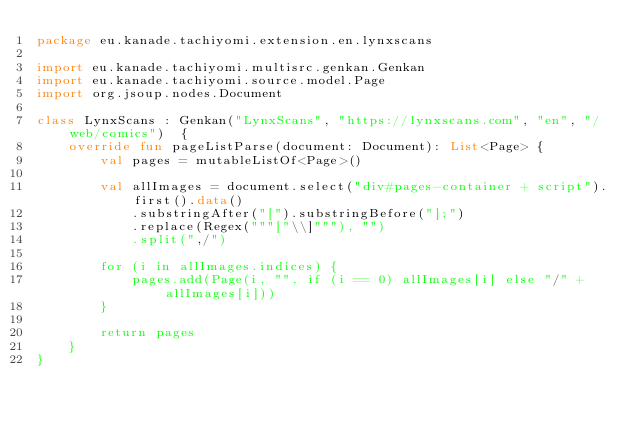Convert code to text. <code><loc_0><loc_0><loc_500><loc_500><_Kotlin_>package eu.kanade.tachiyomi.extension.en.lynxscans

import eu.kanade.tachiyomi.multisrc.genkan.Genkan
import eu.kanade.tachiyomi.source.model.Page
import org.jsoup.nodes.Document

class LynxScans : Genkan("LynxScans", "https://lynxscans.com", "en", "/web/comics")  {
    override fun pageListParse(document: Document): List<Page> {
        val pages = mutableListOf<Page>()

        val allImages = document.select("div#pages-container + script").first().data()
            .substringAfter("[").substringBefore("];")
            .replace(Regex("""["\\]"""), "")
            .split(",/")

        for (i in allImages.indices) {
            pages.add(Page(i, "", if (i == 0) allImages[i] else "/" + allImages[i]))
        }

        return pages
    }
}
</code> 